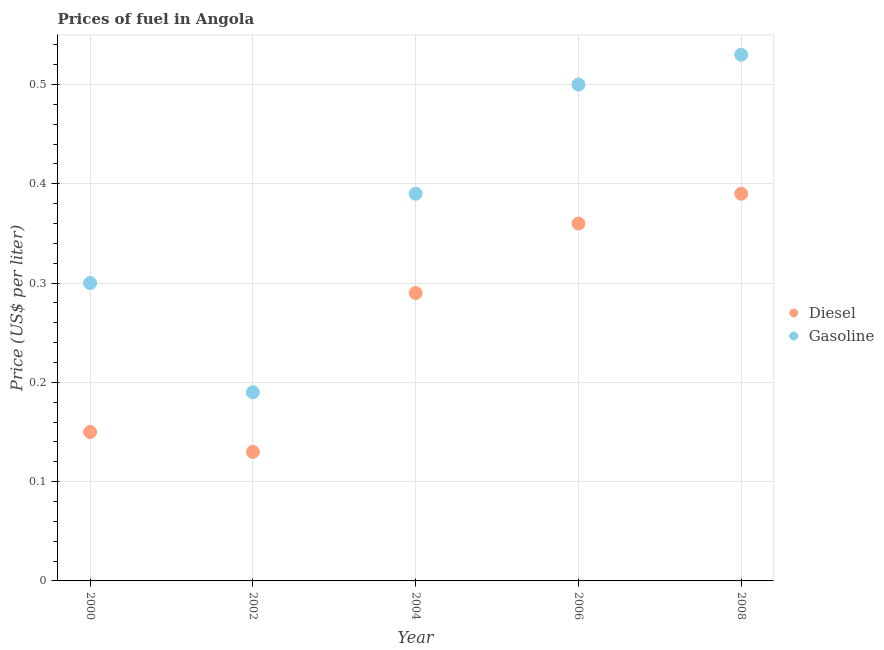How many different coloured dotlines are there?
Your answer should be very brief. 2. What is the gasoline price in 2004?
Provide a short and direct response. 0.39. Across all years, what is the maximum diesel price?
Ensure brevity in your answer.  0.39. Across all years, what is the minimum gasoline price?
Your response must be concise. 0.19. In which year was the diesel price maximum?
Ensure brevity in your answer.  2008. What is the total diesel price in the graph?
Give a very brief answer. 1.32. What is the difference between the diesel price in 2002 and that in 2006?
Keep it short and to the point. -0.23. What is the difference between the gasoline price in 2006 and the diesel price in 2004?
Give a very brief answer. 0.21. What is the average gasoline price per year?
Provide a succinct answer. 0.38. In the year 2008, what is the difference between the gasoline price and diesel price?
Provide a succinct answer. 0.14. What is the ratio of the gasoline price in 2004 to that in 2006?
Your answer should be very brief. 0.78. Is the difference between the gasoline price in 2000 and 2004 greater than the difference between the diesel price in 2000 and 2004?
Ensure brevity in your answer.  Yes. What is the difference between the highest and the second highest diesel price?
Offer a terse response. 0.03. What is the difference between the highest and the lowest diesel price?
Make the answer very short. 0.26. Is the sum of the diesel price in 2002 and 2008 greater than the maximum gasoline price across all years?
Your answer should be very brief. No. Is the diesel price strictly less than the gasoline price over the years?
Offer a terse response. Yes. What is the difference between two consecutive major ticks on the Y-axis?
Give a very brief answer. 0.1. Does the graph contain any zero values?
Provide a succinct answer. No. What is the title of the graph?
Provide a short and direct response. Prices of fuel in Angola. Does "Quality of trade" appear as one of the legend labels in the graph?
Provide a succinct answer. No. What is the label or title of the Y-axis?
Keep it short and to the point. Price (US$ per liter). What is the Price (US$ per liter) in Diesel in 2000?
Ensure brevity in your answer.  0.15. What is the Price (US$ per liter) of Gasoline in 2000?
Make the answer very short. 0.3. What is the Price (US$ per liter) in Diesel in 2002?
Your response must be concise. 0.13. What is the Price (US$ per liter) of Gasoline in 2002?
Give a very brief answer. 0.19. What is the Price (US$ per liter) in Diesel in 2004?
Offer a terse response. 0.29. What is the Price (US$ per liter) in Gasoline in 2004?
Keep it short and to the point. 0.39. What is the Price (US$ per liter) of Diesel in 2006?
Provide a succinct answer. 0.36. What is the Price (US$ per liter) in Gasoline in 2006?
Your answer should be compact. 0.5. What is the Price (US$ per liter) in Diesel in 2008?
Provide a succinct answer. 0.39. What is the Price (US$ per liter) of Gasoline in 2008?
Give a very brief answer. 0.53. Across all years, what is the maximum Price (US$ per liter) in Diesel?
Your answer should be compact. 0.39. Across all years, what is the maximum Price (US$ per liter) in Gasoline?
Offer a very short reply. 0.53. Across all years, what is the minimum Price (US$ per liter) in Diesel?
Keep it short and to the point. 0.13. Across all years, what is the minimum Price (US$ per liter) of Gasoline?
Your answer should be compact. 0.19. What is the total Price (US$ per liter) of Diesel in the graph?
Provide a short and direct response. 1.32. What is the total Price (US$ per liter) of Gasoline in the graph?
Make the answer very short. 1.91. What is the difference between the Price (US$ per liter) of Gasoline in 2000 and that in 2002?
Provide a succinct answer. 0.11. What is the difference between the Price (US$ per liter) in Diesel in 2000 and that in 2004?
Your answer should be compact. -0.14. What is the difference between the Price (US$ per liter) of Gasoline in 2000 and that in 2004?
Your answer should be very brief. -0.09. What is the difference between the Price (US$ per liter) of Diesel in 2000 and that in 2006?
Your answer should be very brief. -0.21. What is the difference between the Price (US$ per liter) in Diesel in 2000 and that in 2008?
Provide a succinct answer. -0.24. What is the difference between the Price (US$ per liter) in Gasoline in 2000 and that in 2008?
Your response must be concise. -0.23. What is the difference between the Price (US$ per liter) in Diesel in 2002 and that in 2004?
Give a very brief answer. -0.16. What is the difference between the Price (US$ per liter) of Diesel in 2002 and that in 2006?
Keep it short and to the point. -0.23. What is the difference between the Price (US$ per liter) in Gasoline in 2002 and that in 2006?
Provide a short and direct response. -0.31. What is the difference between the Price (US$ per liter) of Diesel in 2002 and that in 2008?
Your response must be concise. -0.26. What is the difference between the Price (US$ per liter) of Gasoline in 2002 and that in 2008?
Offer a terse response. -0.34. What is the difference between the Price (US$ per liter) in Diesel in 2004 and that in 2006?
Provide a short and direct response. -0.07. What is the difference between the Price (US$ per liter) in Gasoline in 2004 and that in 2006?
Your response must be concise. -0.11. What is the difference between the Price (US$ per liter) of Diesel in 2004 and that in 2008?
Make the answer very short. -0.1. What is the difference between the Price (US$ per liter) in Gasoline in 2004 and that in 2008?
Keep it short and to the point. -0.14. What is the difference between the Price (US$ per liter) of Diesel in 2006 and that in 2008?
Offer a terse response. -0.03. What is the difference between the Price (US$ per liter) of Gasoline in 2006 and that in 2008?
Give a very brief answer. -0.03. What is the difference between the Price (US$ per liter) of Diesel in 2000 and the Price (US$ per liter) of Gasoline in 2002?
Ensure brevity in your answer.  -0.04. What is the difference between the Price (US$ per liter) of Diesel in 2000 and the Price (US$ per liter) of Gasoline in 2004?
Offer a terse response. -0.24. What is the difference between the Price (US$ per liter) in Diesel in 2000 and the Price (US$ per liter) in Gasoline in 2006?
Ensure brevity in your answer.  -0.35. What is the difference between the Price (US$ per liter) in Diesel in 2000 and the Price (US$ per liter) in Gasoline in 2008?
Make the answer very short. -0.38. What is the difference between the Price (US$ per liter) in Diesel in 2002 and the Price (US$ per liter) in Gasoline in 2004?
Your answer should be very brief. -0.26. What is the difference between the Price (US$ per liter) of Diesel in 2002 and the Price (US$ per liter) of Gasoline in 2006?
Offer a terse response. -0.37. What is the difference between the Price (US$ per liter) in Diesel in 2004 and the Price (US$ per liter) in Gasoline in 2006?
Give a very brief answer. -0.21. What is the difference between the Price (US$ per liter) in Diesel in 2004 and the Price (US$ per liter) in Gasoline in 2008?
Keep it short and to the point. -0.24. What is the difference between the Price (US$ per liter) in Diesel in 2006 and the Price (US$ per liter) in Gasoline in 2008?
Your answer should be compact. -0.17. What is the average Price (US$ per liter) in Diesel per year?
Your response must be concise. 0.26. What is the average Price (US$ per liter) in Gasoline per year?
Offer a very short reply. 0.38. In the year 2000, what is the difference between the Price (US$ per liter) of Diesel and Price (US$ per liter) of Gasoline?
Your response must be concise. -0.15. In the year 2002, what is the difference between the Price (US$ per liter) of Diesel and Price (US$ per liter) of Gasoline?
Your answer should be compact. -0.06. In the year 2006, what is the difference between the Price (US$ per liter) in Diesel and Price (US$ per liter) in Gasoline?
Offer a terse response. -0.14. In the year 2008, what is the difference between the Price (US$ per liter) of Diesel and Price (US$ per liter) of Gasoline?
Keep it short and to the point. -0.14. What is the ratio of the Price (US$ per liter) of Diesel in 2000 to that in 2002?
Your response must be concise. 1.15. What is the ratio of the Price (US$ per liter) of Gasoline in 2000 to that in 2002?
Give a very brief answer. 1.58. What is the ratio of the Price (US$ per liter) of Diesel in 2000 to that in 2004?
Offer a terse response. 0.52. What is the ratio of the Price (US$ per liter) in Gasoline in 2000 to that in 2004?
Offer a very short reply. 0.77. What is the ratio of the Price (US$ per liter) in Diesel in 2000 to that in 2006?
Ensure brevity in your answer.  0.42. What is the ratio of the Price (US$ per liter) of Diesel in 2000 to that in 2008?
Give a very brief answer. 0.38. What is the ratio of the Price (US$ per liter) of Gasoline in 2000 to that in 2008?
Your answer should be very brief. 0.57. What is the ratio of the Price (US$ per liter) in Diesel in 2002 to that in 2004?
Provide a short and direct response. 0.45. What is the ratio of the Price (US$ per liter) of Gasoline in 2002 to that in 2004?
Give a very brief answer. 0.49. What is the ratio of the Price (US$ per liter) in Diesel in 2002 to that in 2006?
Provide a succinct answer. 0.36. What is the ratio of the Price (US$ per liter) in Gasoline in 2002 to that in 2006?
Your response must be concise. 0.38. What is the ratio of the Price (US$ per liter) of Gasoline in 2002 to that in 2008?
Offer a very short reply. 0.36. What is the ratio of the Price (US$ per liter) in Diesel in 2004 to that in 2006?
Make the answer very short. 0.81. What is the ratio of the Price (US$ per liter) of Gasoline in 2004 to that in 2006?
Ensure brevity in your answer.  0.78. What is the ratio of the Price (US$ per liter) in Diesel in 2004 to that in 2008?
Your answer should be very brief. 0.74. What is the ratio of the Price (US$ per liter) of Gasoline in 2004 to that in 2008?
Your response must be concise. 0.74. What is the ratio of the Price (US$ per liter) in Gasoline in 2006 to that in 2008?
Your response must be concise. 0.94. What is the difference between the highest and the second highest Price (US$ per liter) of Diesel?
Offer a terse response. 0.03. What is the difference between the highest and the lowest Price (US$ per liter) of Diesel?
Offer a very short reply. 0.26. What is the difference between the highest and the lowest Price (US$ per liter) of Gasoline?
Your answer should be very brief. 0.34. 